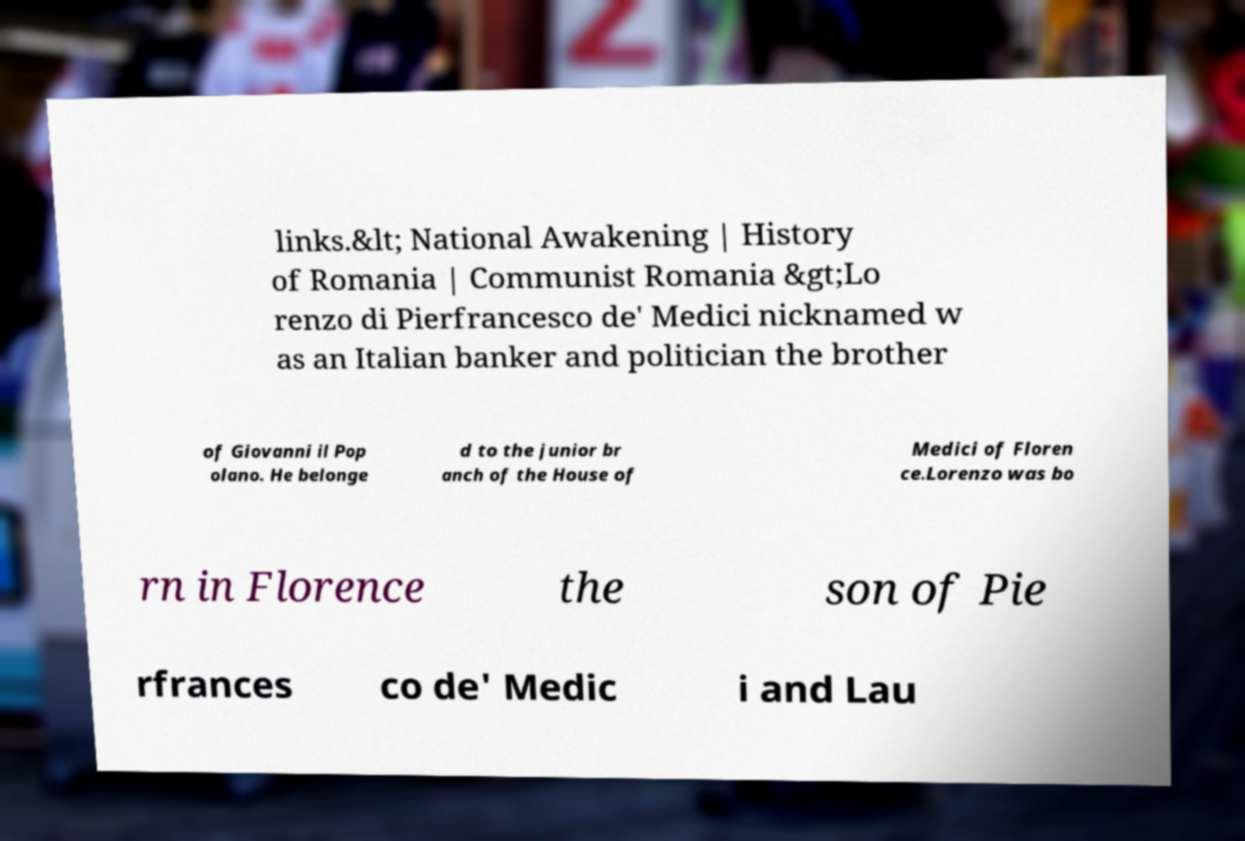For documentation purposes, I need the text within this image transcribed. Could you provide that? links.&lt; National Awakening | History of Romania | Communist Romania &gt;Lo renzo di Pierfrancesco de' Medici nicknamed w as an Italian banker and politician the brother of Giovanni il Pop olano. He belonge d to the junior br anch of the House of Medici of Floren ce.Lorenzo was bo rn in Florence the son of Pie rfrances co de' Medic i and Lau 